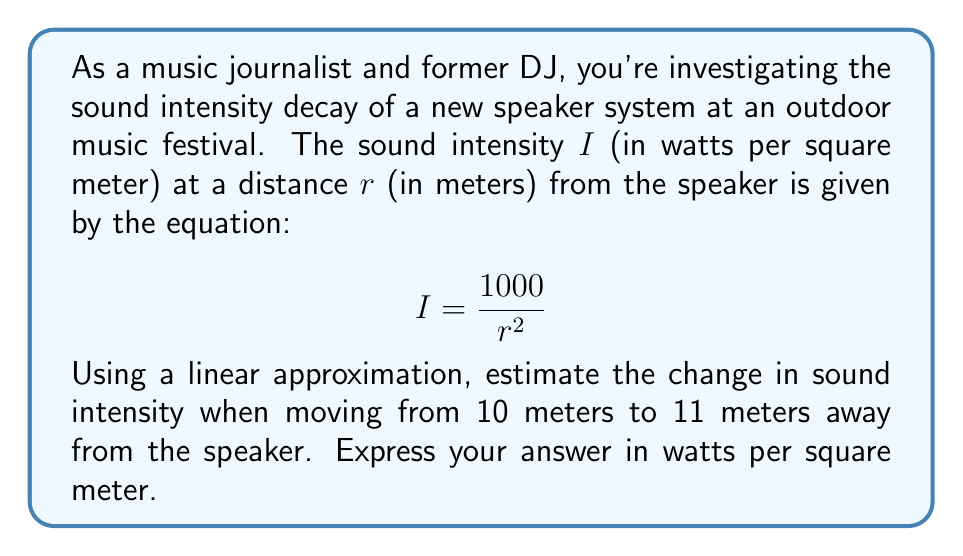What is the answer to this math problem? To solve this problem, we'll use the concept of linear approximation, which is based on the derivative of the function.

1) First, let's find the derivative of the intensity function with respect to r:

   $$ \frac{dI}{dr} = -\frac{2000}{r^3} $$

2) The linear approximation formula is:

   $$ \Delta I \approx \frac{dI}{dr} \cdot \Delta r $$

   where $\Delta I$ is the change in intensity and $\Delta r$ is the change in distance.

3) We need to evaluate the derivative at r = 10 meters:

   $$ \left.\frac{dI}{dr}\right|_{r=10} = -\frac{2000}{10^3} = -2 \text{ W/m}^2\text{/m} $$

4) The change in distance $\Delta r$ is 11 - 10 = 1 meter.

5) Now we can apply the linear approximation:

   $$ \Delta I \approx -2 \cdot 1 = -2 \text{ W/m}^2 $$

Therefore, the estimated change in sound intensity when moving from 10 meters to 11 meters away from the speaker is approximately -2 watts per square meter.
Answer: $-2 \text{ W/m}^2$ 